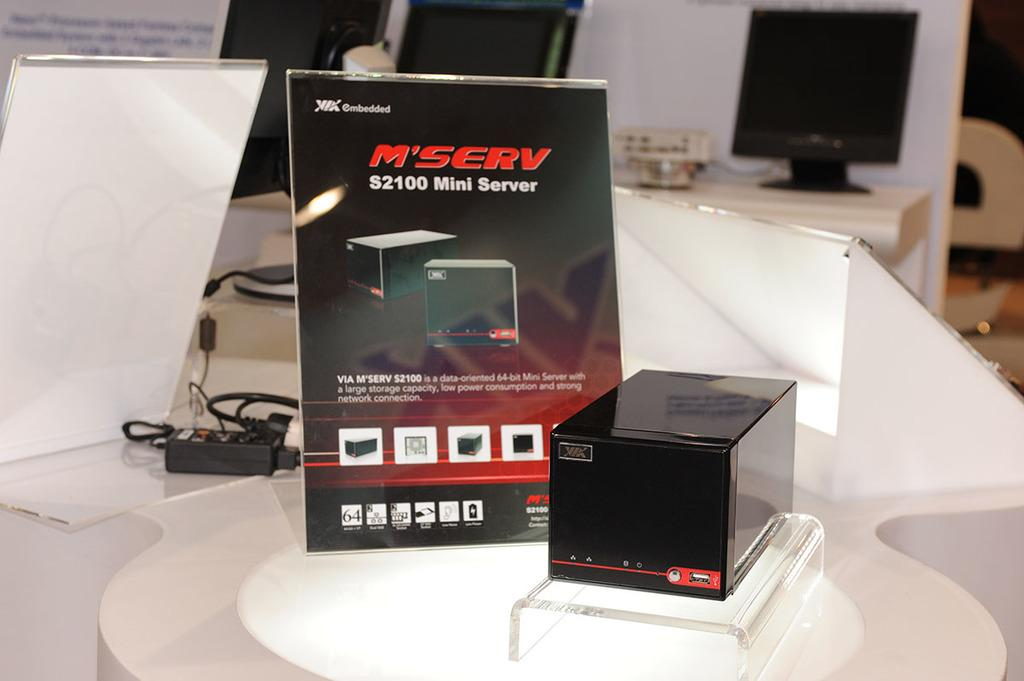<image>
Share a concise interpretation of the image provided. Black sign that says S2100 Mini Server next to a small black box. 